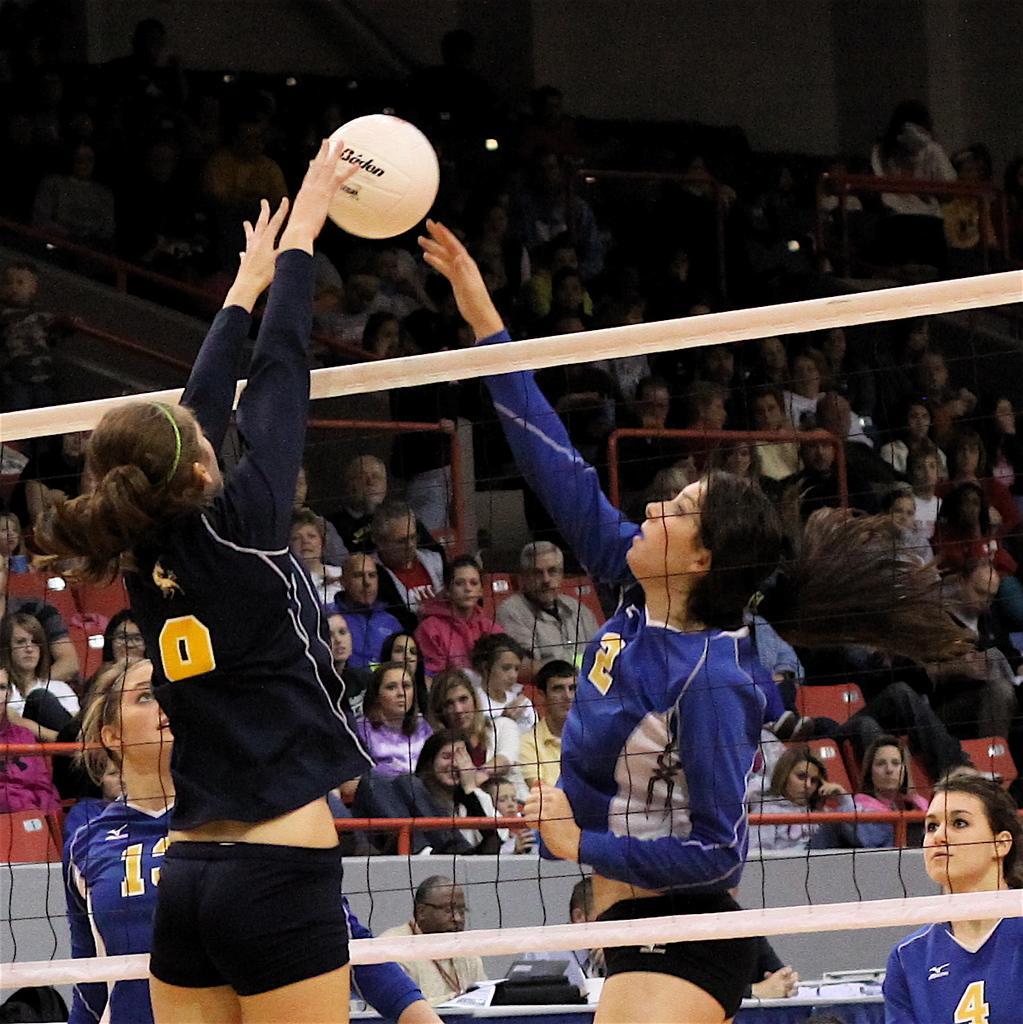Please provide a concise description of this image. In this picture I can see few women's are playing with ball in between the net, side few people are sitting in front of the table on which I can see some objects are placed, behind so many people are sitting and watching. 